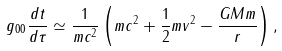Convert formula to latex. <formula><loc_0><loc_0><loc_500><loc_500>g _ { 0 0 } \frac { d t } { d \tau } \simeq \frac { 1 } { m c ^ { 2 } } \left ( m c ^ { 2 } + \frac { 1 } { 2 } m v ^ { 2 } - \frac { G M m } { r } \right ) ,</formula> 